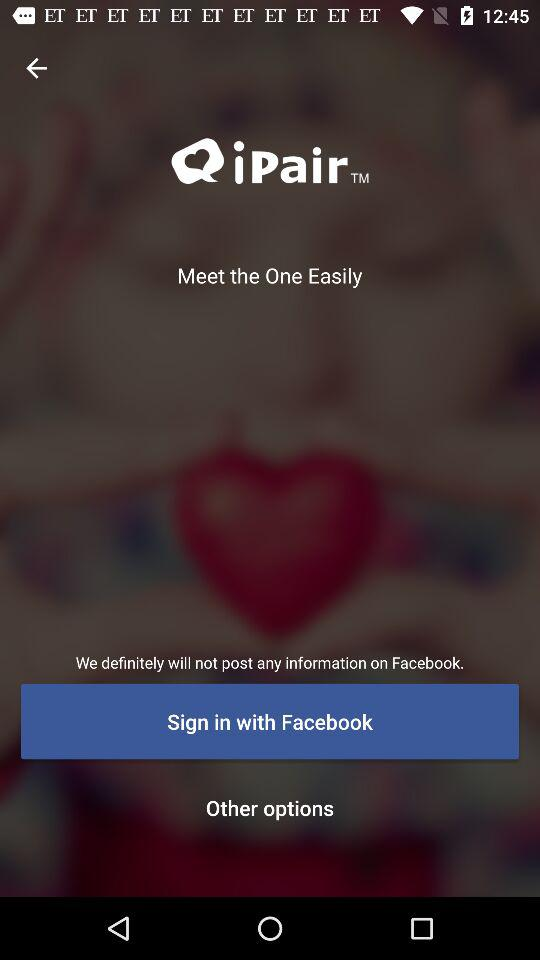What is the sign-in option? The sign-in option is "Facebook". 